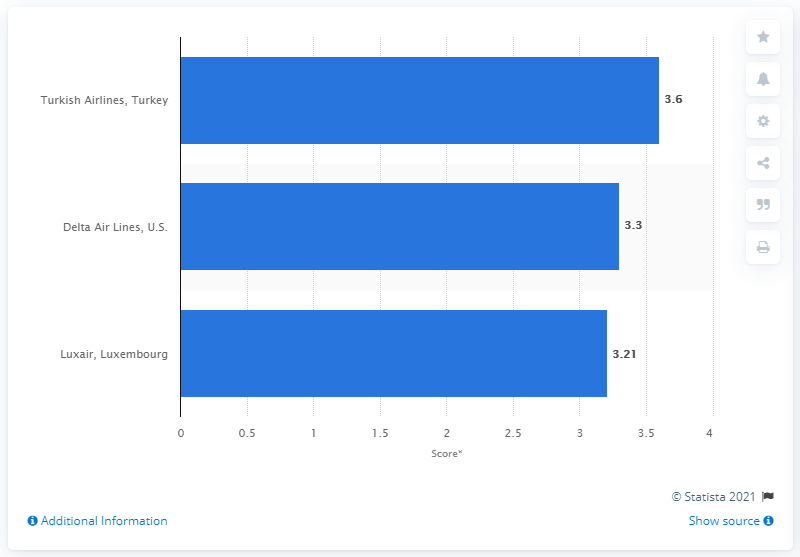Outline some significant characteristics in this image. The score of Turkish Airlines was 3.6 out of five. 